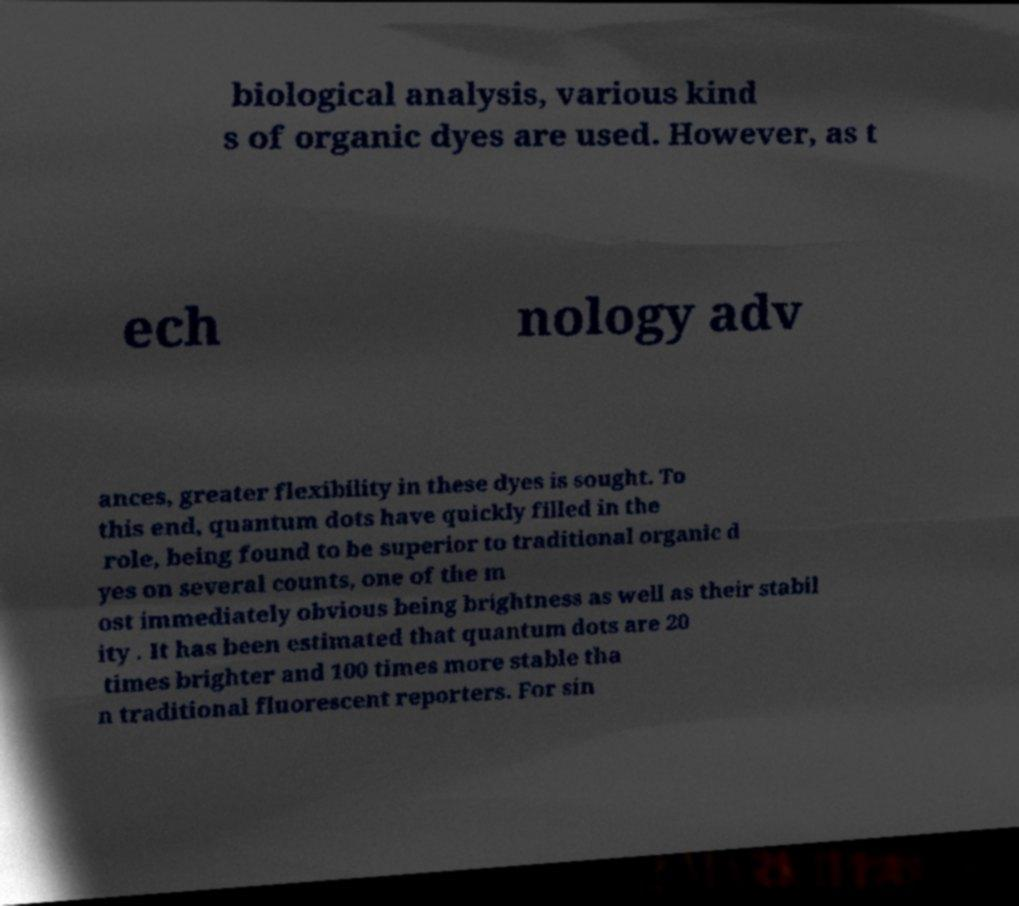Please read and relay the text visible in this image. What does it say? biological analysis, various kind s of organic dyes are used. However, as t ech nology adv ances, greater flexibility in these dyes is sought. To this end, quantum dots have quickly filled in the role, being found to be superior to traditional organic d yes on several counts, one of the m ost immediately obvious being brightness as well as their stabil ity . It has been estimated that quantum dots are 20 times brighter and 100 times more stable tha n traditional fluorescent reporters. For sin 